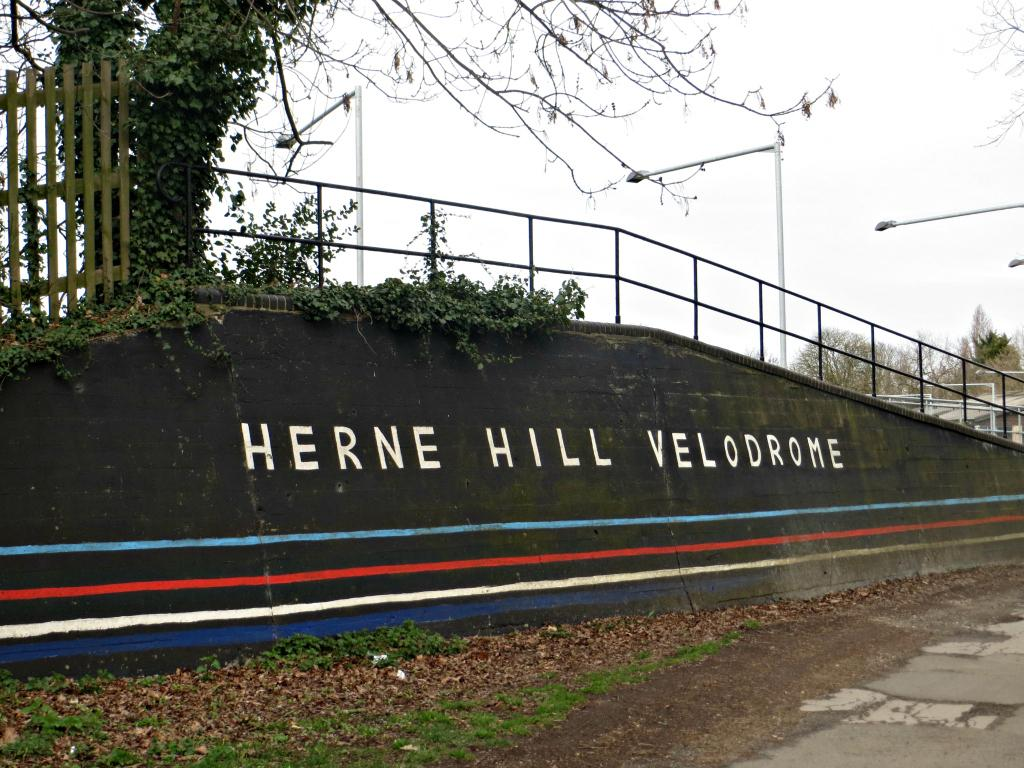<image>
Present a compact description of the photo's key features. A wall with Herne Hill Velodrome written on it. 